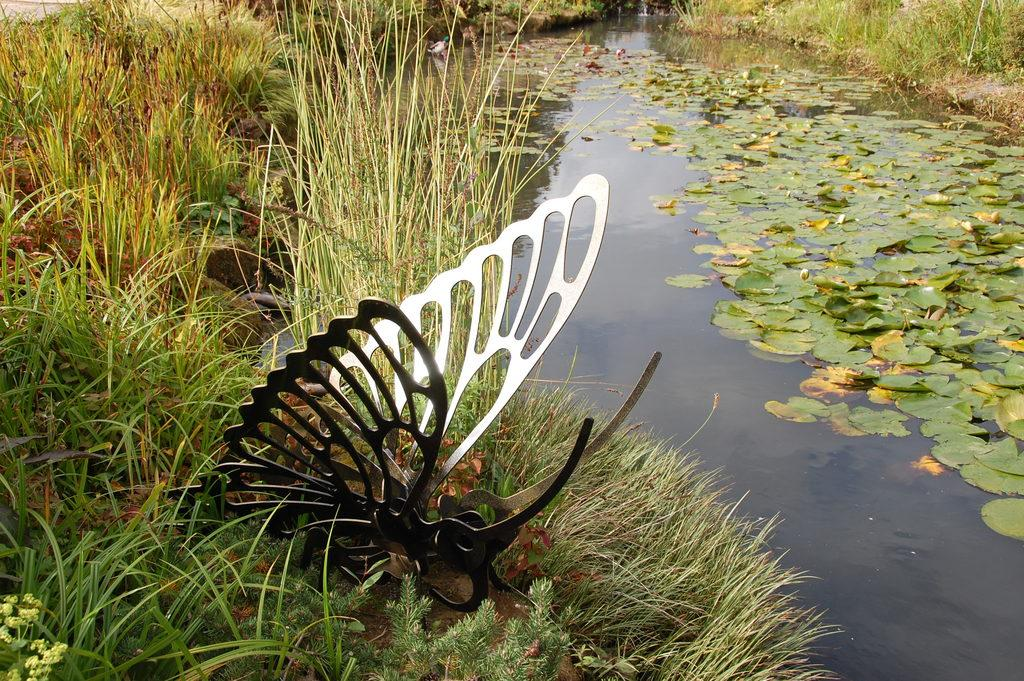What is the main subject of the image? There is a butterfly made with metal on the grass. What can be seen in the background of the image? Leaves are visible on the water, grass is present, and there is a duck in the background. What type of religion is practiced by the parent in the image? There is no parent present in the image, and therefore no religion can be associated with them. 